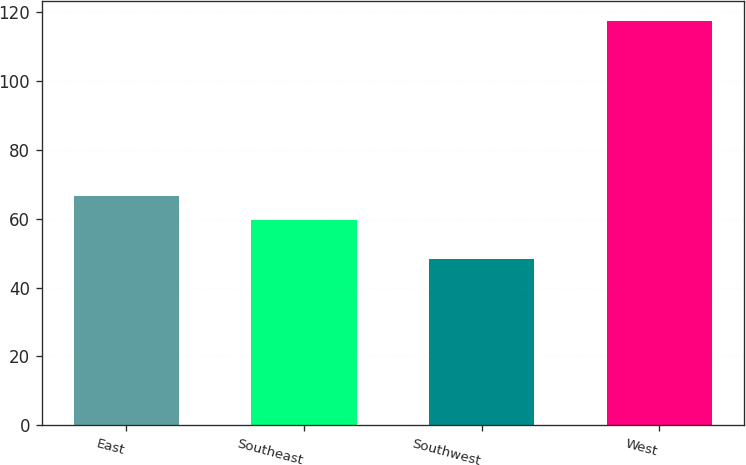Convert chart. <chart><loc_0><loc_0><loc_500><loc_500><bar_chart><fcel>East<fcel>Southeast<fcel>Southwest<fcel>West<nl><fcel>66.59<fcel>59.7<fcel>48.3<fcel>117.2<nl></chart> 